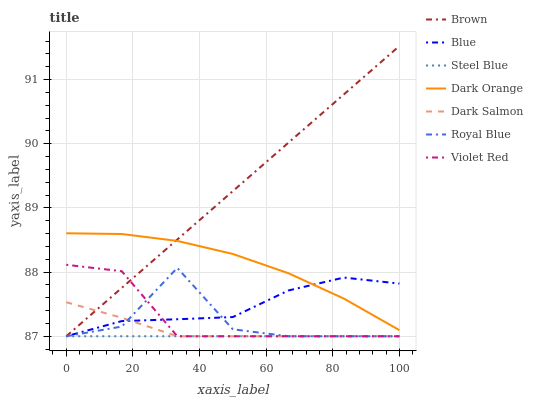Does Steel Blue have the minimum area under the curve?
Answer yes or no. Yes. Does Brown have the maximum area under the curve?
Answer yes or no. Yes. Does Violet Red have the minimum area under the curve?
Answer yes or no. No. Does Violet Red have the maximum area under the curve?
Answer yes or no. No. Is Steel Blue the smoothest?
Answer yes or no. Yes. Is Royal Blue the roughest?
Answer yes or no. Yes. Is Brown the smoothest?
Answer yes or no. No. Is Brown the roughest?
Answer yes or no. No. Does Dark Orange have the lowest value?
Answer yes or no. No. Does Brown have the highest value?
Answer yes or no. Yes. Does Violet Red have the highest value?
Answer yes or no. No. Is Violet Red less than Dark Orange?
Answer yes or no. Yes. Is Dark Orange greater than Steel Blue?
Answer yes or no. Yes. Does Dark Orange intersect Brown?
Answer yes or no. Yes. Is Dark Orange less than Brown?
Answer yes or no. No. Is Dark Orange greater than Brown?
Answer yes or no. No. Does Violet Red intersect Dark Orange?
Answer yes or no. No. 